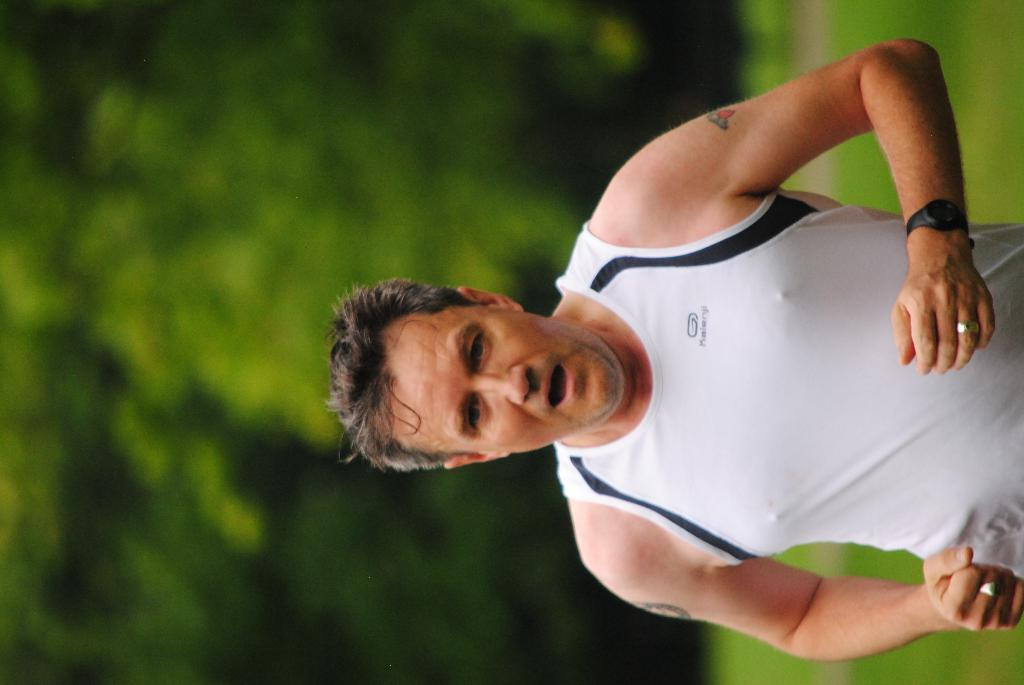What is the main subject of the image? There is a person in the image. Can you describe the background of the image? The background of the image is blurred. What is the person in the image wearing? The person is wearing clothes. Can you identify any accessories the person is wearing? The person is wearing a watch. What type of hair is visible on the person's head in the image? There is no hair visible on the person's head in the image, as the person is wearing a helmet or hat that covers their hair. 